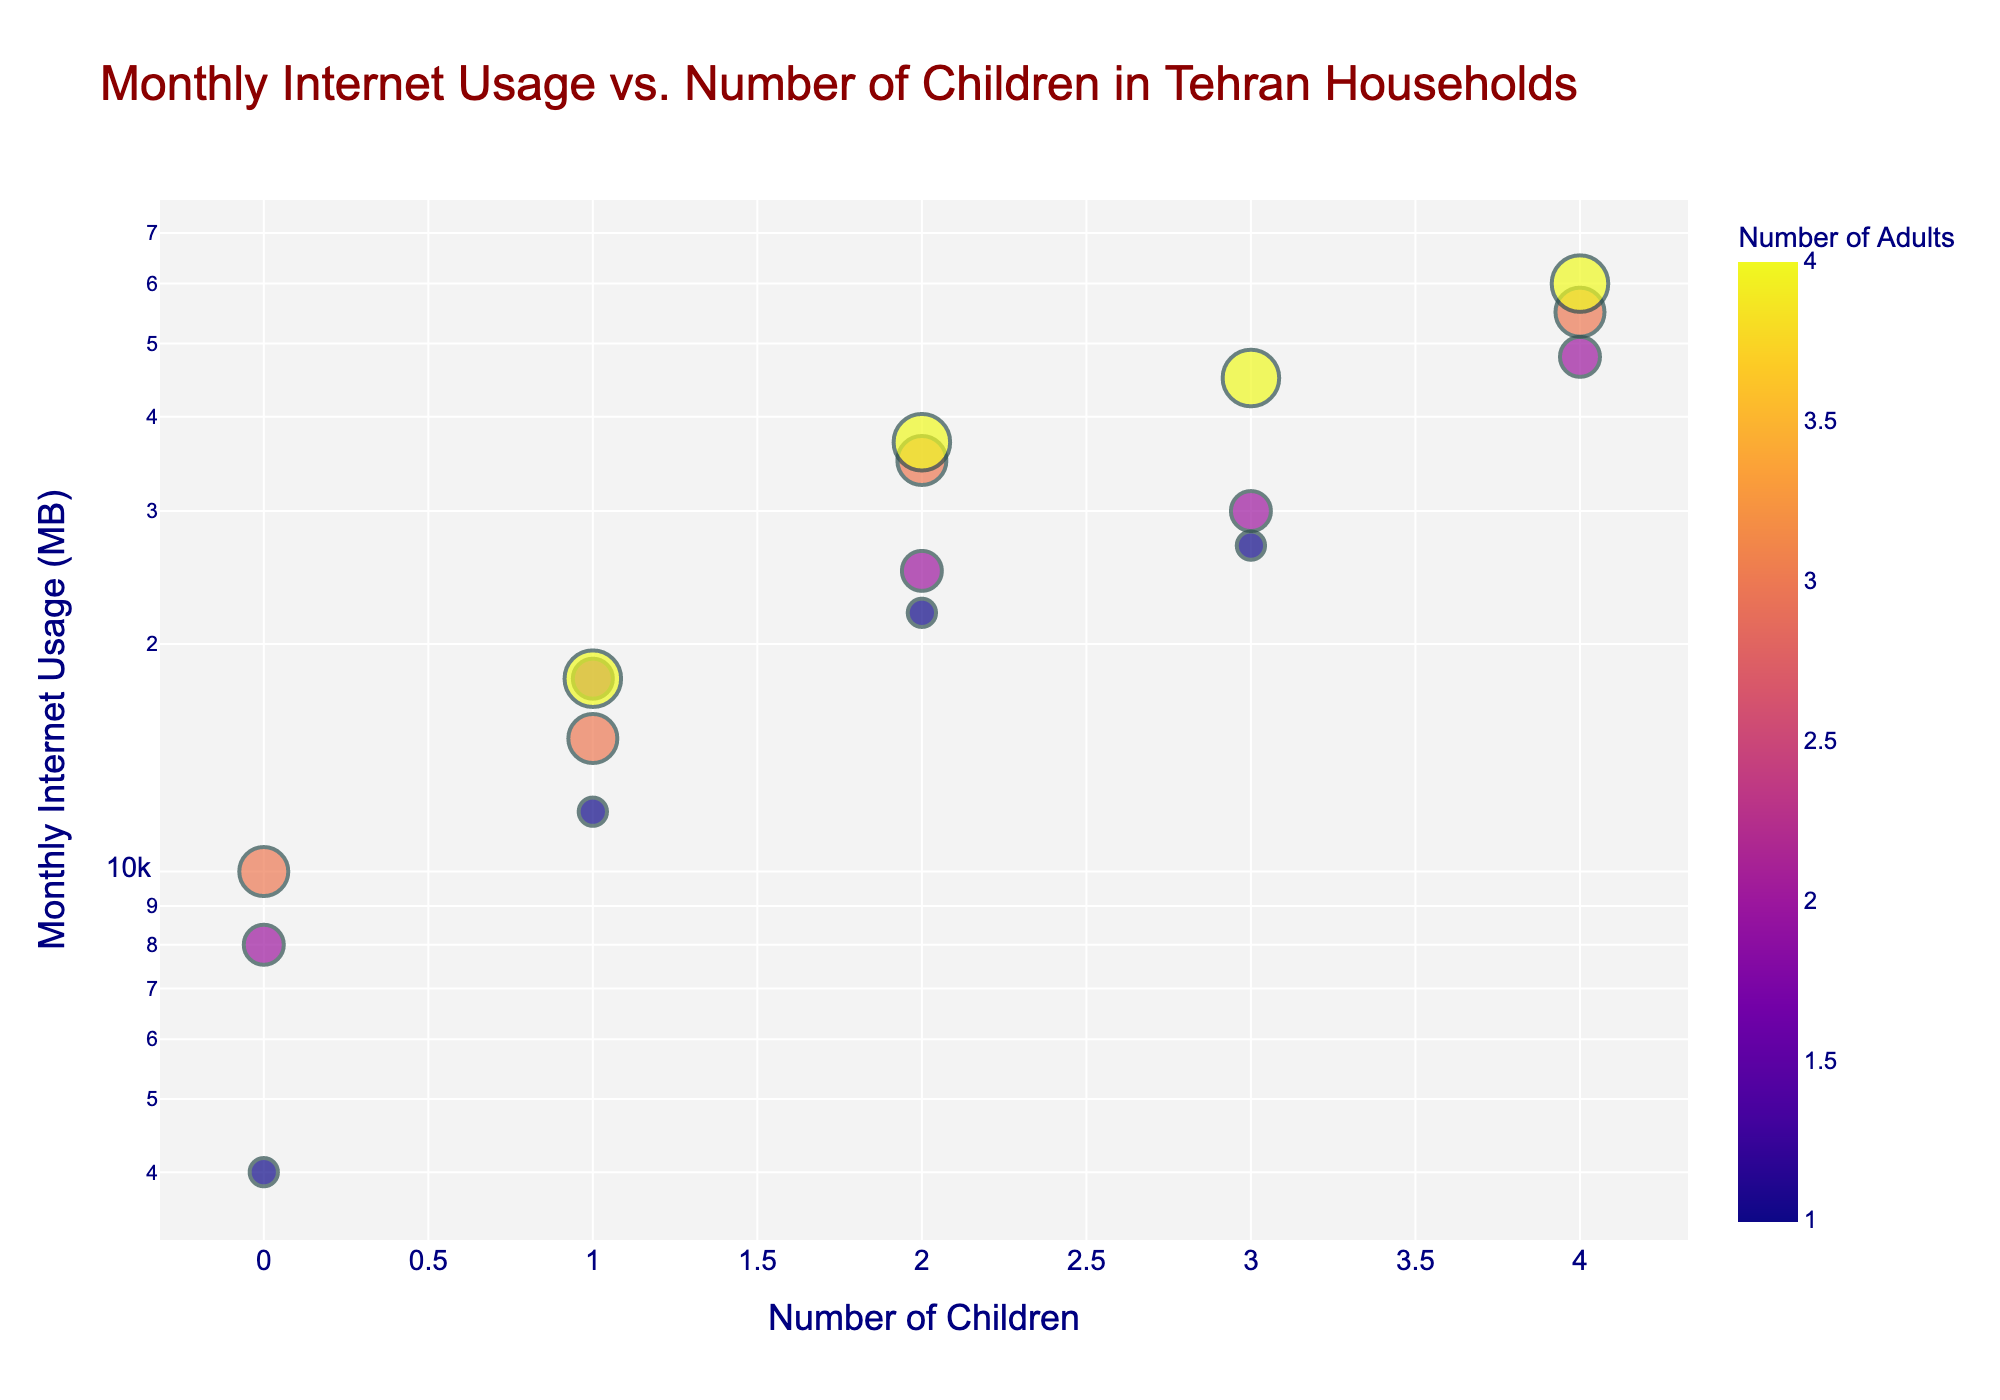What's the title of the figure? The title is usually located at the top of the figure and provides a summary of the visualized data. In this case, it reads "Monthly Internet Usage vs. Number of Children in Tehran Households".
Answer: Monthly Internet Usage vs. Number of Children in Tehran Households What are the labels of the X and Y axes? The X and Y axes labels provide context for what the respective axes represent. Here, the X axis is labeled "Number of Children" and the Y axis is labeled "Monthly Internet Usage (MB)".
Answer: Number of Children and Monthly Internet Usage (MB) How are the sizes of the data points determined? The size of each data point is determined by the "Number of Adults" in each household. Larger points indicate more adults. This relationship can be inferred by correlating the size variation with the legend or hover text that shows the number of adults.
Answer: Number of Adults What's the maximum Monthly Internet Usage depicted in the figure? To find the maximum Monthly Internet Usage, look for the highest point along the Y axis. The highest Y value is 60000 MB for a household with 4 children and 4 adults.
Answer: 60000 MB Which household has the lowest Monthly Internet Usage and how much is it? Identify the lowest point on the Y axis to determine the household with the lowest usage. Household_4 has the lowest monthly usage at 4000 MB.
Answer: Household_4, 4000 MB What trend do you observe between the number of children and monthly internet usage? The trend can be observed by looking at the overall distribution of data points. Generally, as the number of children increases, the monthly internet usage tends to increase as well.
Answer: Internet usage increases with the number of children Which household has the highest number of children and also the highest internet usage? Look for the data point with the highest number of children and also check its corresponding internet usage. Household_17 with 4 children has the highest internet usage at 60000 MB.
Answer: Household_17 Is there a clear relationship between the number of adults and internet usage? Observe the sizes and colors of the points. Larger data points, representing more adults, generally tend to cluster towards higher internet usage, indicating a possible trend.
Answer: More adults tend to use more internet What would the monthly internet usage be for a household with 0 children and the average of 1, 2, and 3 adults? To calculate this, find the average internet usage for households with 0 children and 1, 2, and 3 adults, with internet usage values: 4000, 8000, and 10000 MB. (4000 + 8000 + 10000) ÷ 3 = 7333.33 MB.
Answer: 7333.33 MB 